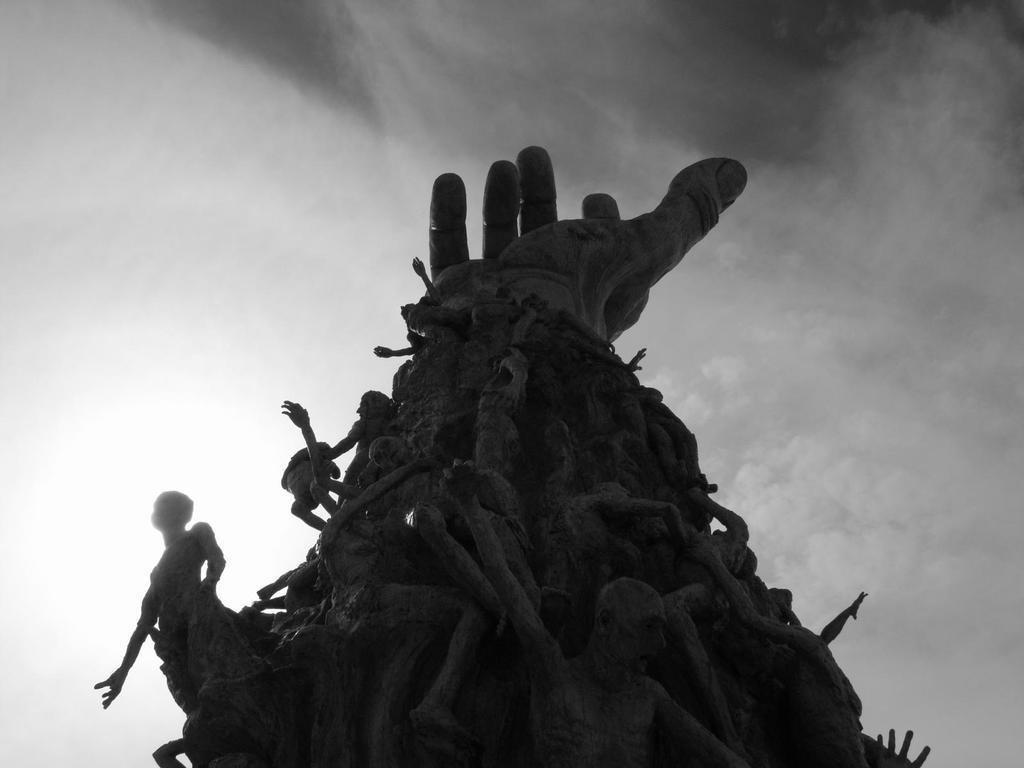What is the main subject of the image? The main subject of the image is a statue of a person's hand. What is unique about the hand statue? There are statues of persons on the hand. What can be seen in the background of the image? There are clouds in the sky in the background of the image. How does the person on the hand maintain their grip on the statue? The image does not show any person on the hand attempting to grip the statue, as the statues are stationary. Can you tell me how many people are swimming in the image? There is no swimming activity depicted in the image; it features a statue of a hand with statues of persons on it. 